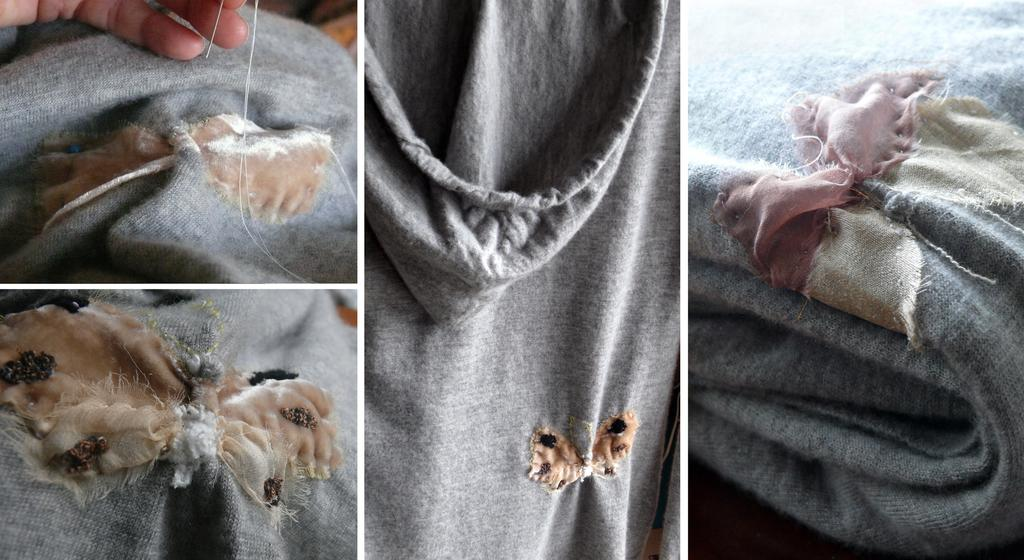What is the main subject of the image? The image contains a collage of four pictures. What are the pictures depicting? The pictures depict clothes. Can you describe any additional elements in the image? There is a hand of a person at the left top of the collage. What type of canvas is being used to hold the spoon and wine in the image? There is no canvas, spoon, or wine present in the image. The image contains a collage of four pictures depicting clothes and a hand at the left top of the collage. 